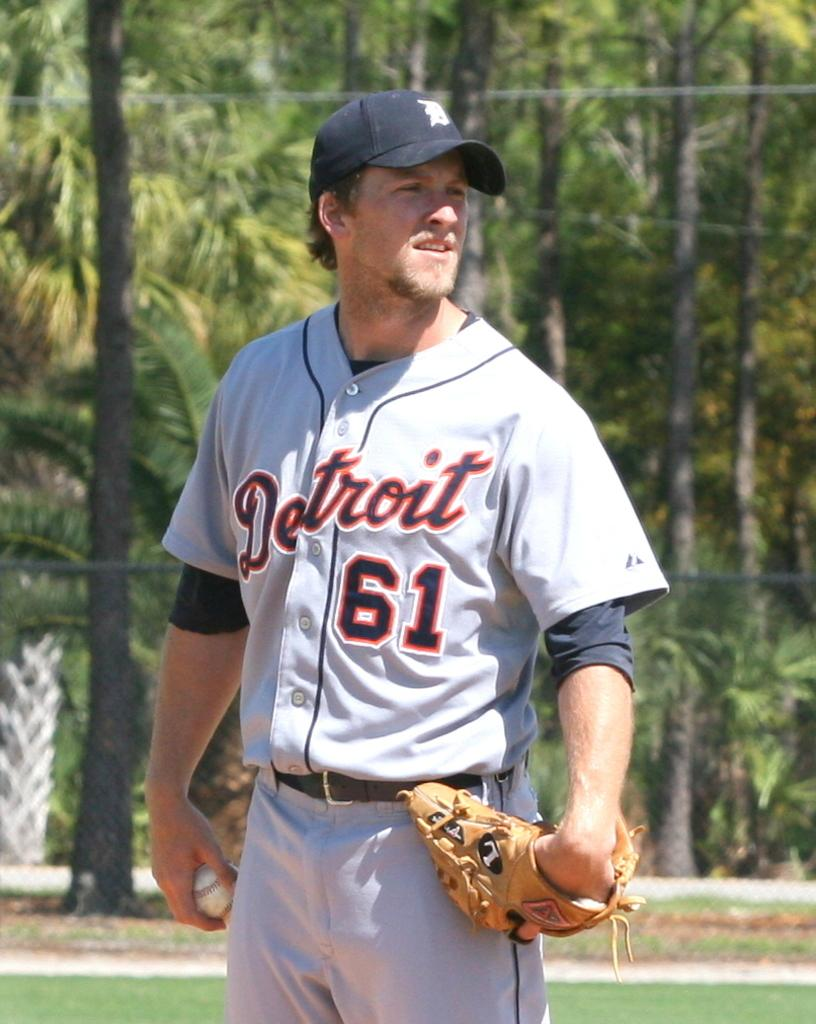<image>
Give a short and clear explanation of the subsequent image. A uniformed Detroit baseball player holds the ball in an alert position. 